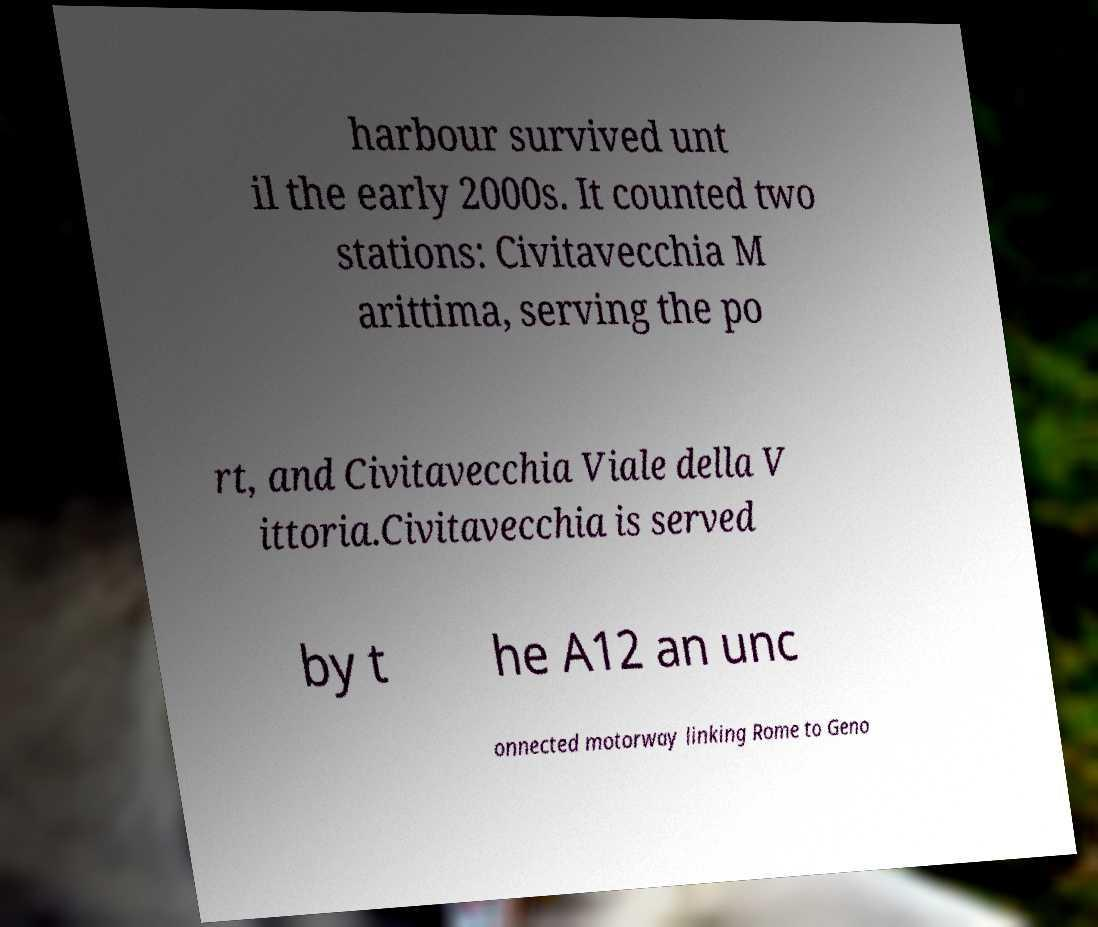Could you extract and type out the text from this image? harbour survived unt il the early 2000s. It counted two stations: Civitavecchia M arittima, serving the po rt, and Civitavecchia Viale della V ittoria.Civitavecchia is served by t he A12 an unc onnected motorway linking Rome to Geno 